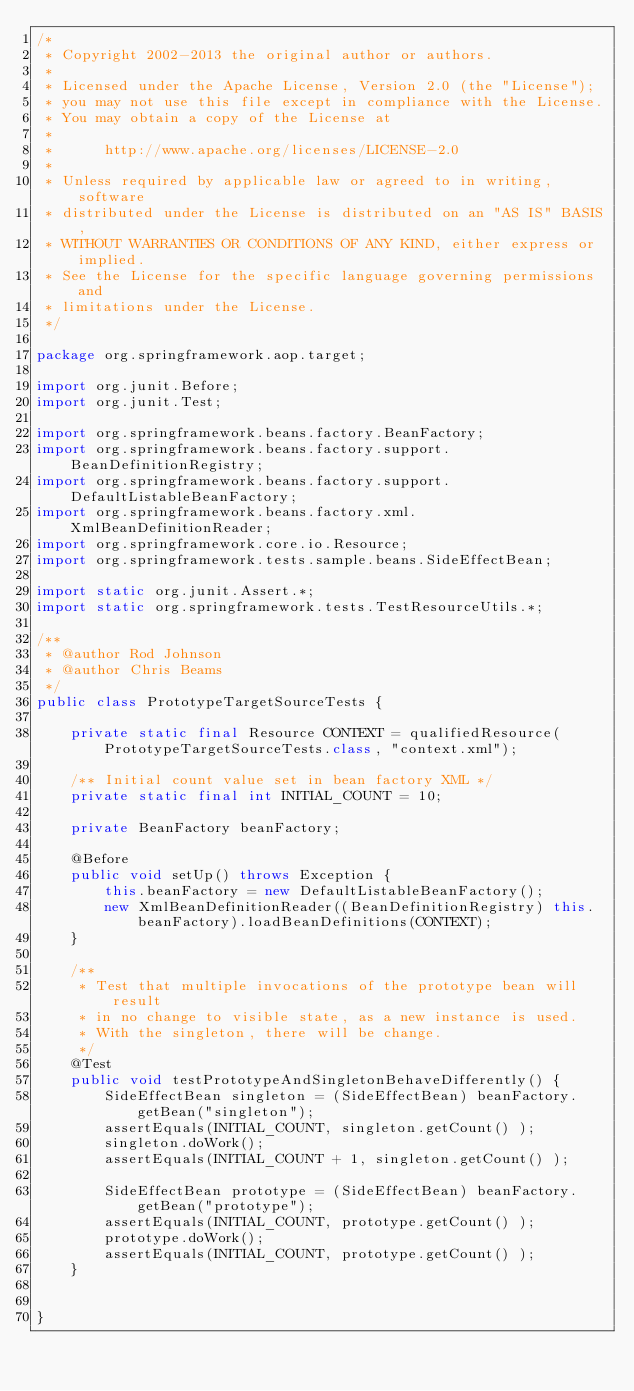Convert code to text. <code><loc_0><loc_0><loc_500><loc_500><_Java_>/*
 * Copyright 2002-2013 the original author or authors.
 *
 * Licensed under the Apache License, Version 2.0 (the "License");
 * you may not use this file except in compliance with the License.
 * You may obtain a copy of the License at
 *
 *      http://www.apache.org/licenses/LICENSE-2.0
 *
 * Unless required by applicable law or agreed to in writing, software
 * distributed under the License is distributed on an "AS IS" BASIS,
 * WITHOUT WARRANTIES OR CONDITIONS OF ANY KIND, either express or implied.
 * See the License for the specific language governing permissions and
 * limitations under the License.
 */

package org.springframework.aop.target;

import org.junit.Before;
import org.junit.Test;

import org.springframework.beans.factory.BeanFactory;
import org.springframework.beans.factory.support.BeanDefinitionRegistry;
import org.springframework.beans.factory.support.DefaultListableBeanFactory;
import org.springframework.beans.factory.xml.XmlBeanDefinitionReader;
import org.springframework.core.io.Resource;
import org.springframework.tests.sample.beans.SideEffectBean;

import static org.junit.Assert.*;
import static org.springframework.tests.TestResourceUtils.*;

/**
 * @author Rod Johnson
 * @author Chris Beams
 */
public class PrototypeTargetSourceTests {

	private static final Resource CONTEXT = qualifiedResource(PrototypeTargetSourceTests.class, "context.xml");

	/** Initial count value set in bean factory XML */
	private static final int INITIAL_COUNT = 10;

	private BeanFactory beanFactory;

	@Before
	public void setUp() throws Exception {
		this.beanFactory = new DefaultListableBeanFactory();
		new XmlBeanDefinitionReader((BeanDefinitionRegistry) this.beanFactory).loadBeanDefinitions(CONTEXT);
	}

	/**
	 * Test that multiple invocations of the prototype bean will result
	 * in no change to visible state, as a new instance is used.
	 * With the singleton, there will be change.
	 */
	@Test
	public void testPrototypeAndSingletonBehaveDifferently() {
		SideEffectBean singleton = (SideEffectBean) beanFactory.getBean("singleton");
		assertEquals(INITIAL_COUNT, singleton.getCount() );
		singleton.doWork();
		assertEquals(INITIAL_COUNT + 1, singleton.getCount() );

		SideEffectBean prototype = (SideEffectBean) beanFactory.getBean("prototype");
		assertEquals(INITIAL_COUNT, prototype.getCount() );
		prototype.doWork();
		assertEquals(INITIAL_COUNT, prototype.getCount() );
	}


}
</code> 